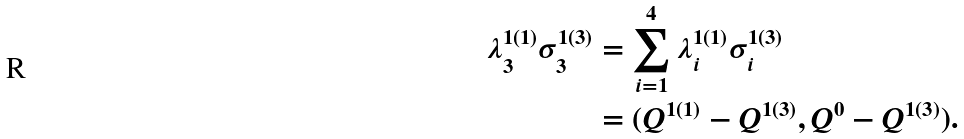Convert formula to latex. <formula><loc_0><loc_0><loc_500><loc_500>\lambda ^ { 1 ( 1 ) } _ { 3 } \sigma ^ { 1 ( 3 ) } _ { 3 } & = \sum _ { i = 1 } ^ { 4 } \lambda ^ { 1 ( 1 ) } _ { i } \sigma ^ { 1 ( 3 ) } _ { i } \\ & = ( Q ^ { 1 ( 1 ) } - Q ^ { 1 ( 3 ) } , Q ^ { 0 } - Q ^ { 1 ( 3 ) } ) .</formula> 